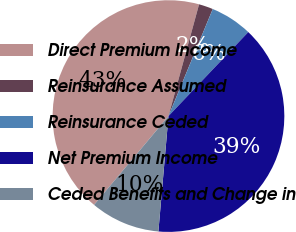Convert chart to OTSL. <chart><loc_0><loc_0><loc_500><loc_500><pie_chart><fcel>Direct Premium Income<fcel>Reinsurance Assumed<fcel>Reinsurance Ceded<fcel>Net Premium Income<fcel>Ceded Benefits and Change in<nl><fcel>43.15%<fcel>1.99%<fcel>5.85%<fcel>39.29%<fcel>9.71%<nl></chart> 